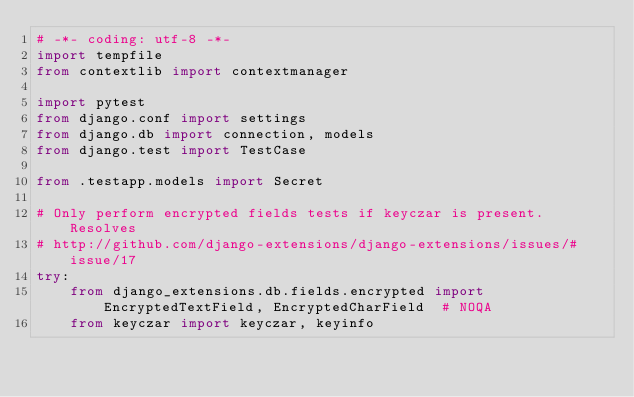<code> <loc_0><loc_0><loc_500><loc_500><_Python_># -*- coding: utf-8 -*-
import tempfile
from contextlib import contextmanager

import pytest
from django.conf import settings
from django.db import connection, models
from django.test import TestCase

from .testapp.models import Secret

# Only perform encrypted fields tests if keyczar is present. Resolves
# http://github.com/django-extensions/django-extensions/issues/#issue/17
try:
    from django_extensions.db.fields.encrypted import EncryptedTextField, EncryptedCharField  # NOQA
    from keyczar import keyczar, keyinfo</code> 